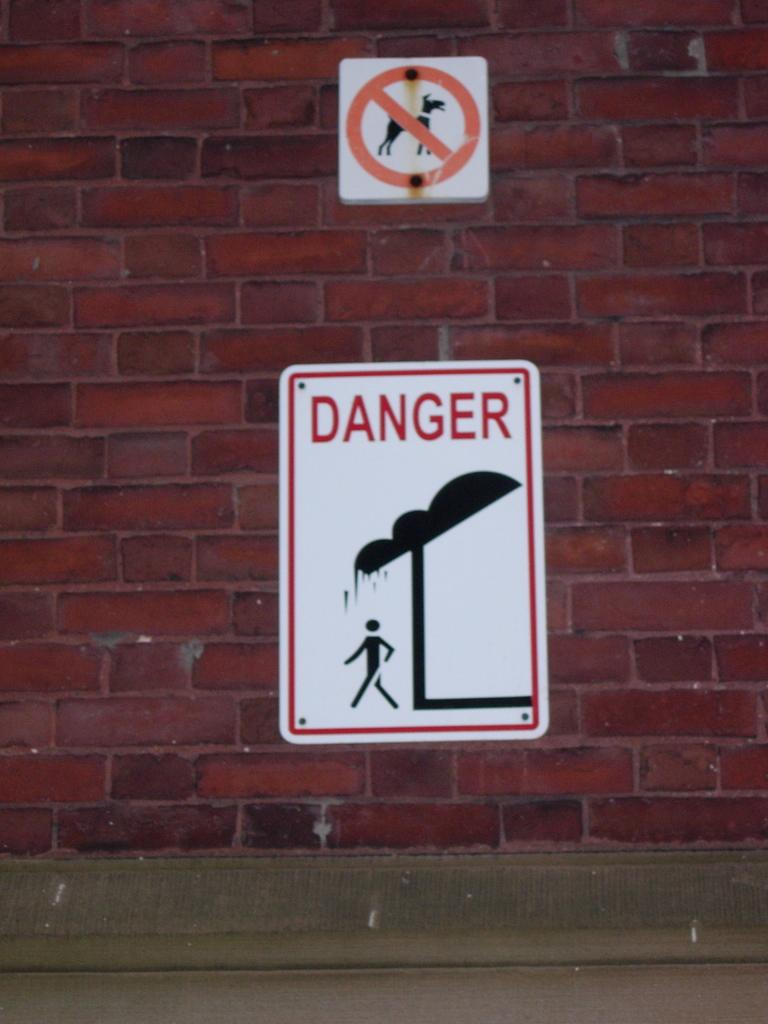<image>
Provide a brief description of the given image. The sign tries to warn people of danger. 